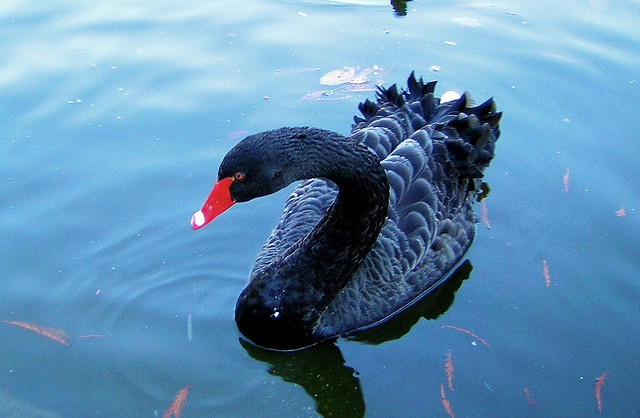Describe the objects in this image and their specific colors. I can see a bird in lightblue, black, navy, blue, and gray tones in this image. 